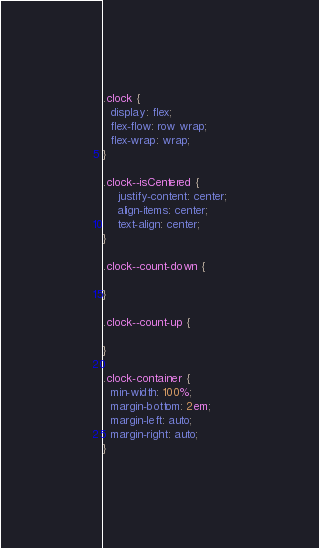<code> <loc_0><loc_0><loc_500><loc_500><_CSS_>.clock {
  display: flex;
  flex-flow: row wrap;
  flex-wrap: wrap;
}

.clock--isCentered {
  	justify-content: center;
  	align-items: center;
    text-align: center;
}

.clock--count-down {

}

.clock--count-up {

}

.clock-container {
  min-width: 100%;
  margin-bottom: 2em;
  margin-left: auto;
  margin-right: auto;
}
</code> 